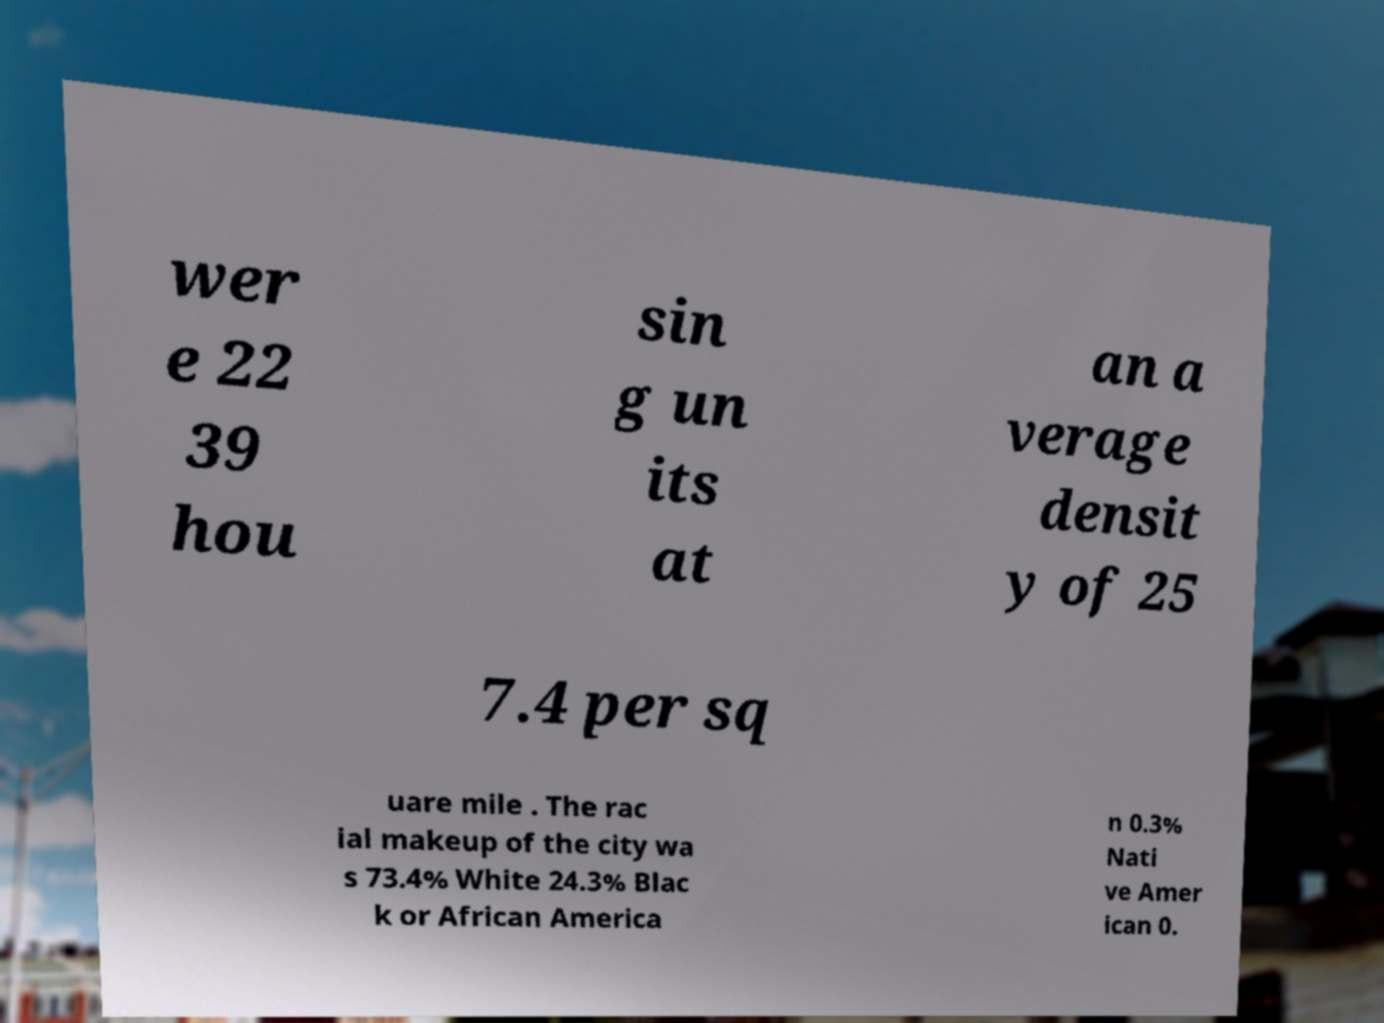Can you read and provide the text displayed in the image?This photo seems to have some interesting text. Can you extract and type it out for me? wer e 22 39 hou sin g un its at an a verage densit y of 25 7.4 per sq uare mile . The rac ial makeup of the city wa s 73.4% White 24.3% Blac k or African America n 0.3% Nati ve Amer ican 0. 